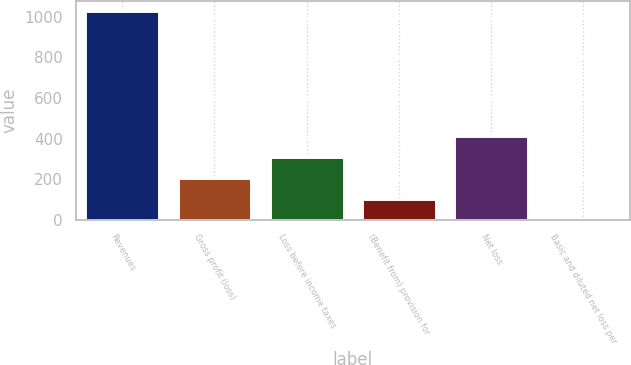Convert chart to OTSL. <chart><loc_0><loc_0><loc_500><loc_500><bar_chart><fcel>Revenues<fcel>Gross profit (loss)<fcel>Loss before income taxes<fcel>(Benefit from) provision for<fcel>Net loss<fcel>Basic and diluted net loss per<nl><fcel>1028.9<fcel>206.37<fcel>309.19<fcel>103.55<fcel>412.01<fcel>0.73<nl></chart> 